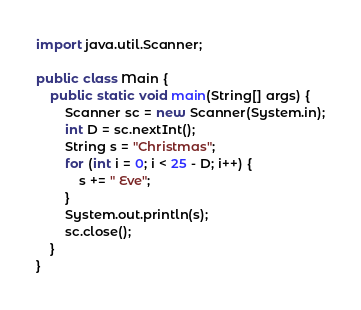<code> <loc_0><loc_0><loc_500><loc_500><_Java_>import java.util.Scanner;

public class Main {
    public static void main(String[] args) {
        Scanner sc = new Scanner(System.in);
        int D = sc.nextInt();
        String s = "Christmas";
        for (int i = 0; i < 25 - D; i++) {
            s += " Eve";
        }
        System.out.println(s);
        sc.close();
    }
}</code> 